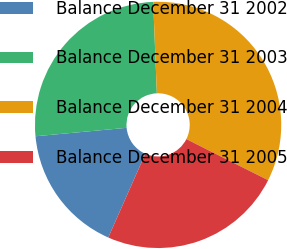<chart> <loc_0><loc_0><loc_500><loc_500><pie_chart><fcel>Balance December 31 2002<fcel>Balance December 31 2003<fcel>Balance December 31 2004<fcel>Balance December 31 2005<nl><fcel>16.9%<fcel>25.84%<fcel>33.05%<fcel>24.22%<nl></chart> 